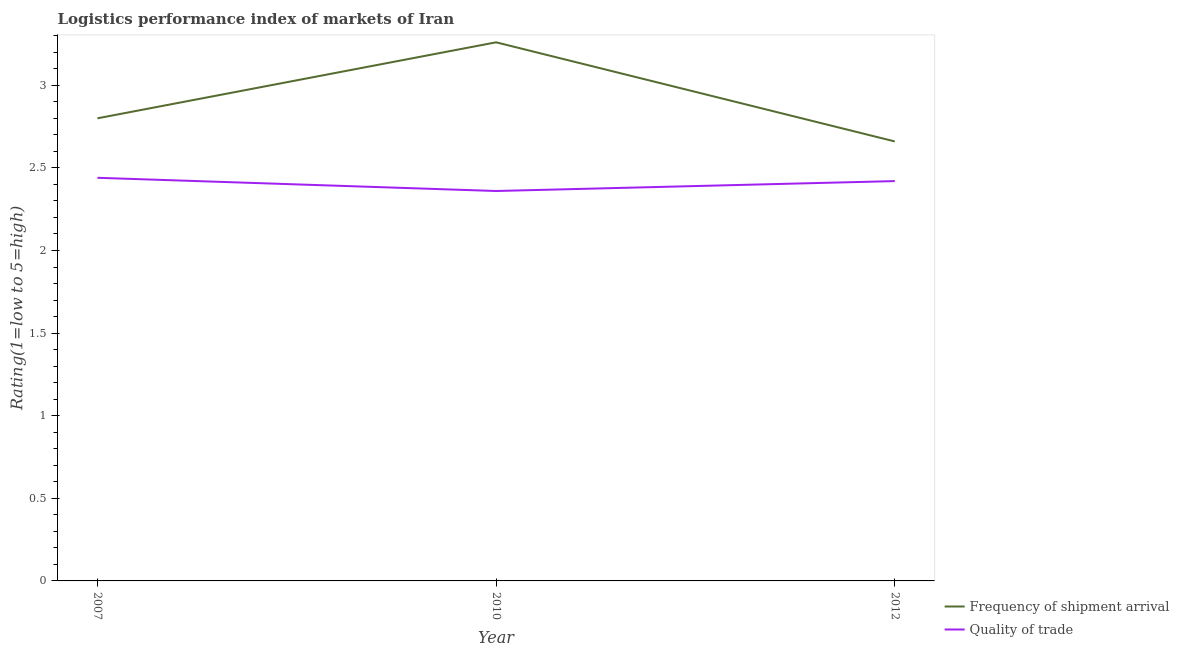Is the number of lines equal to the number of legend labels?
Provide a short and direct response. Yes. What is the lpi quality of trade in 2012?
Provide a succinct answer. 2.42. Across all years, what is the maximum lpi quality of trade?
Make the answer very short. 2.44. Across all years, what is the minimum lpi of frequency of shipment arrival?
Offer a terse response. 2.66. What is the total lpi quality of trade in the graph?
Keep it short and to the point. 7.22. What is the difference between the lpi quality of trade in 2007 and that in 2010?
Give a very brief answer. 0.08. What is the difference between the lpi of frequency of shipment arrival in 2012 and the lpi quality of trade in 2007?
Offer a very short reply. 0.22. What is the average lpi of frequency of shipment arrival per year?
Make the answer very short. 2.91. In the year 2012, what is the difference between the lpi of frequency of shipment arrival and lpi quality of trade?
Provide a succinct answer. 0.24. In how many years, is the lpi quality of trade greater than 2.1?
Ensure brevity in your answer.  3. What is the ratio of the lpi of frequency of shipment arrival in 2007 to that in 2010?
Ensure brevity in your answer.  0.86. Is the difference between the lpi quality of trade in 2007 and 2012 greater than the difference between the lpi of frequency of shipment arrival in 2007 and 2012?
Make the answer very short. No. What is the difference between the highest and the second highest lpi quality of trade?
Give a very brief answer. 0.02. What is the difference between the highest and the lowest lpi of frequency of shipment arrival?
Your answer should be very brief. 0.6. In how many years, is the lpi quality of trade greater than the average lpi quality of trade taken over all years?
Ensure brevity in your answer.  2. Is the sum of the lpi quality of trade in 2010 and 2012 greater than the maximum lpi of frequency of shipment arrival across all years?
Your answer should be very brief. Yes. Is the lpi of frequency of shipment arrival strictly greater than the lpi quality of trade over the years?
Offer a very short reply. Yes. Is the lpi quality of trade strictly less than the lpi of frequency of shipment arrival over the years?
Provide a succinct answer. Yes. What is the difference between two consecutive major ticks on the Y-axis?
Offer a very short reply. 0.5. Are the values on the major ticks of Y-axis written in scientific E-notation?
Provide a succinct answer. No. Does the graph contain any zero values?
Your response must be concise. No. How are the legend labels stacked?
Your response must be concise. Vertical. What is the title of the graph?
Ensure brevity in your answer.  Logistics performance index of markets of Iran. What is the label or title of the Y-axis?
Offer a terse response. Rating(1=low to 5=high). What is the Rating(1=low to 5=high) of Quality of trade in 2007?
Provide a succinct answer. 2.44. What is the Rating(1=low to 5=high) of Frequency of shipment arrival in 2010?
Your answer should be compact. 3.26. What is the Rating(1=low to 5=high) of Quality of trade in 2010?
Your answer should be very brief. 2.36. What is the Rating(1=low to 5=high) of Frequency of shipment arrival in 2012?
Offer a terse response. 2.66. What is the Rating(1=low to 5=high) of Quality of trade in 2012?
Keep it short and to the point. 2.42. Across all years, what is the maximum Rating(1=low to 5=high) of Frequency of shipment arrival?
Provide a short and direct response. 3.26. Across all years, what is the maximum Rating(1=low to 5=high) of Quality of trade?
Your response must be concise. 2.44. Across all years, what is the minimum Rating(1=low to 5=high) in Frequency of shipment arrival?
Keep it short and to the point. 2.66. Across all years, what is the minimum Rating(1=low to 5=high) in Quality of trade?
Your answer should be compact. 2.36. What is the total Rating(1=low to 5=high) of Frequency of shipment arrival in the graph?
Keep it short and to the point. 8.72. What is the total Rating(1=low to 5=high) in Quality of trade in the graph?
Your response must be concise. 7.22. What is the difference between the Rating(1=low to 5=high) in Frequency of shipment arrival in 2007 and that in 2010?
Offer a very short reply. -0.46. What is the difference between the Rating(1=low to 5=high) of Frequency of shipment arrival in 2007 and that in 2012?
Offer a very short reply. 0.14. What is the difference between the Rating(1=low to 5=high) of Quality of trade in 2010 and that in 2012?
Offer a very short reply. -0.06. What is the difference between the Rating(1=low to 5=high) in Frequency of shipment arrival in 2007 and the Rating(1=low to 5=high) in Quality of trade in 2010?
Ensure brevity in your answer.  0.44. What is the difference between the Rating(1=low to 5=high) in Frequency of shipment arrival in 2007 and the Rating(1=low to 5=high) in Quality of trade in 2012?
Your answer should be very brief. 0.38. What is the difference between the Rating(1=low to 5=high) in Frequency of shipment arrival in 2010 and the Rating(1=low to 5=high) in Quality of trade in 2012?
Your response must be concise. 0.84. What is the average Rating(1=low to 5=high) in Frequency of shipment arrival per year?
Your response must be concise. 2.91. What is the average Rating(1=low to 5=high) of Quality of trade per year?
Provide a succinct answer. 2.41. In the year 2007, what is the difference between the Rating(1=low to 5=high) in Frequency of shipment arrival and Rating(1=low to 5=high) in Quality of trade?
Offer a very short reply. 0.36. In the year 2012, what is the difference between the Rating(1=low to 5=high) of Frequency of shipment arrival and Rating(1=low to 5=high) of Quality of trade?
Your answer should be compact. 0.24. What is the ratio of the Rating(1=low to 5=high) in Frequency of shipment arrival in 2007 to that in 2010?
Make the answer very short. 0.86. What is the ratio of the Rating(1=low to 5=high) in Quality of trade in 2007 to that in 2010?
Offer a terse response. 1.03. What is the ratio of the Rating(1=low to 5=high) in Frequency of shipment arrival in 2007 to that in 2012?
Your answer should be compact. 1.05. What is the ratio of the Rating(1=low to 5=high) of Quality of trade in 2007 to that in 2012?
Give a very brief answer. 1.01. What is the ratio of the Rating(1=low to 5=high) of Frequency of shipment arrival in 2010 to that in 2012?
Provide a short and direct response. 1.23. What is the ratio of the Rating(1=low to 5=high) in Quality of trade in 2010 to that in 2012?
Ensure brevity in your answer.  0.98. What is the difference between the highest and the second highest Rating(1=low to 5=high) of Frequency of shipment arrival?
Your answer should be very brief. 0.46. What is the difference between the highest and the second highest Rating(1=low to 5=high) in Quality of trade?
Provide a short and direct response. 0.02. 